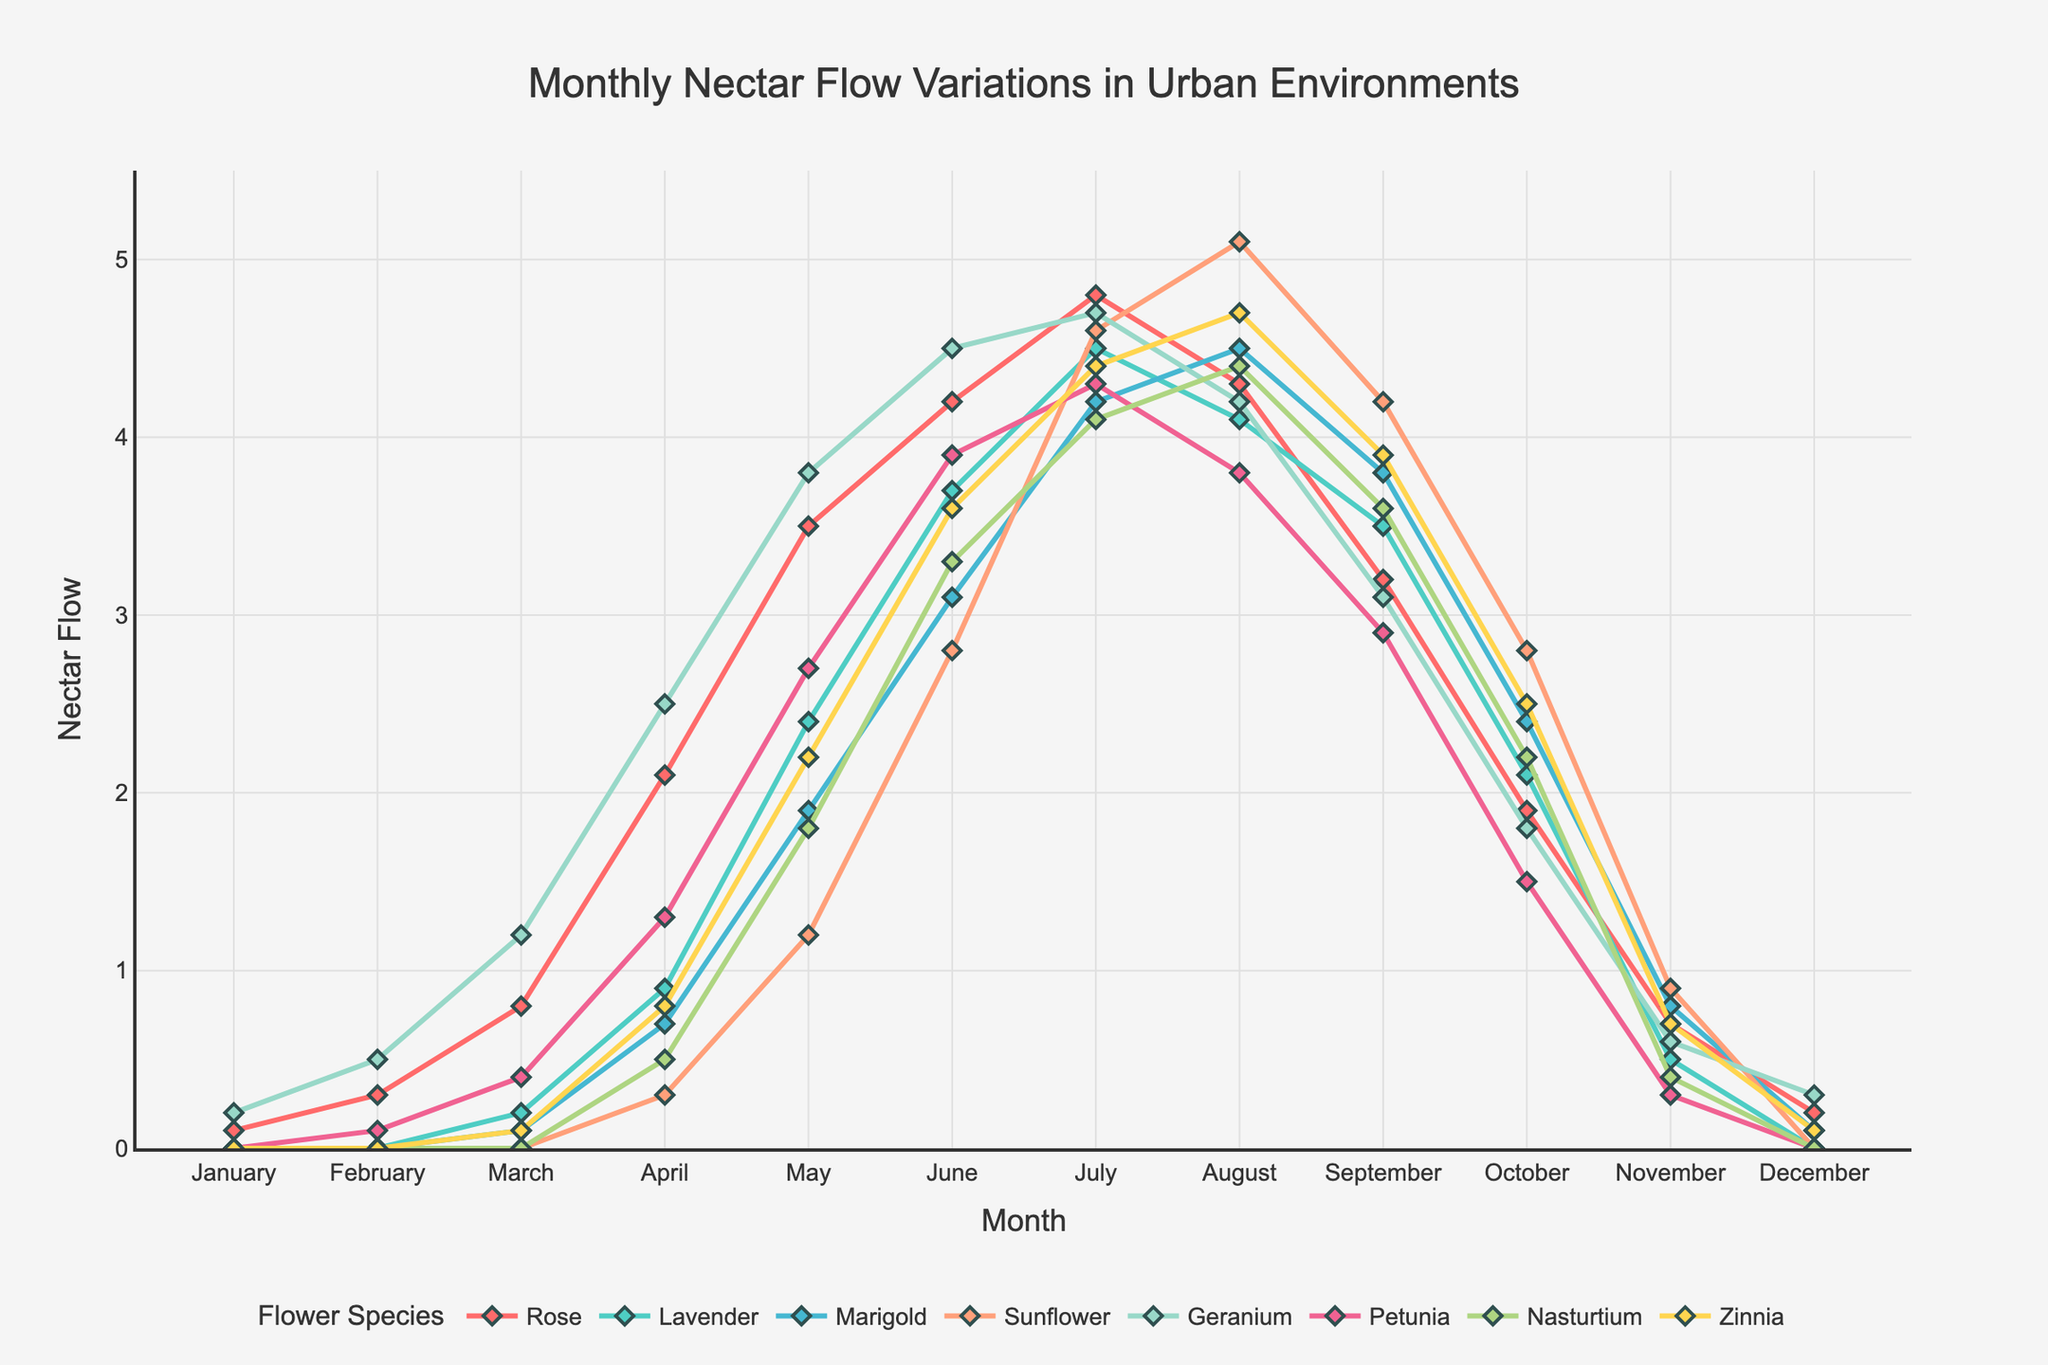What are the flower species with the highest nectar flow in July? To determine the flower species with the highest nectar flow in July, observe the nectar flow values for each flower species in July on the line chart. The values are highest for Sunflower and Rose, both above 4.6.
Answer: Sunflower and Rose Which month has the highest overall nectar flow for Petunia, and what is its value? Trace the Petunia line on the chart to find the highest point. This occurs in July, with a nectar flow around 4.3.
Answer: July, 4.3 How does the nectar flow of Lavender in August compare to that of Geranium in the same month? Compare the heights of the Lavender and Geranium lines in August. Lavender has slightly higher nectar flow than Geranium; Lavender is around 4.1, and Geranium is 4.2.
Answer: Lavender is higher What is the difference in nectar flow between March and October for Nasturtium? Identify the values for Nasturtium in March and October on the chart. In March, it is about 0 and in October, it is around 2.2. Subtract: 2.2 - 0 = 2.2.
Answer: 2.2 Which flower species shows the most rapid increase in nectar flow from January to April? Examine the lines from January to April. The Rose line has the steepest incline, showing the most rapid increase from about 0.1 to around 2.1.
Answer: Rose What is the average nectar flow in June for Marigold and Geranium? Check the June values: Marigold is approximately 3.1, and Geranium is approximately 4.5. Average: (3.1 + 4.5) / 2 = 3.8.
Answer: 3.8 In which month do Zinnia and Lavender have the same value of nectar flow, and what is that value? Find the intersection point where Zinnia and Lavender lines meet. In April, both have the same value of roughly 0.9.
Answer: April, 0.9 How does the nectar flow trend of Sunflower from May to August compare with Petunia in the same period? Compare the slopes of Sunflower and Petunia lines between May and August. Sunflower increases steadily to about 5.1, whereas Petunia rises to a peak of approximately 4.3 in July. Thus, Sunflower has a steeper upward trend.
Answer: Sunflower has a steeper trend Which flower species has the lowest nectar flow in December, and what is its value? Check the values for December. Lavender and Sunflower both are at approximately 0.0, indicating the lowest values.
Answer: Lavender and Sunflower, 0.0 